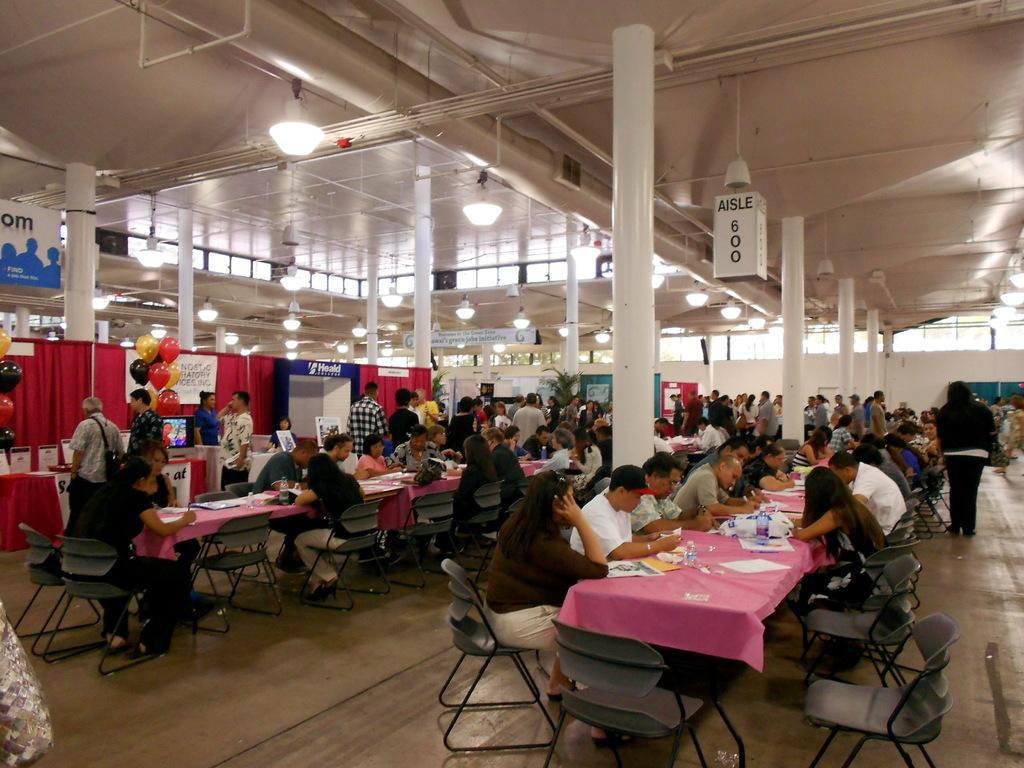What are the people in the image doing? There is a group of people seated on chairs, and some people are standing. What can be seen on the tables in the image? There are papers on the tables. What decorative items are present in the image? Balloons are present in the image. Can you tell me how many mice are hiding under the chairs in the image? There are no mice present in the image; it only shows people seated on chairs, standing, papers on tables, and balloons. 